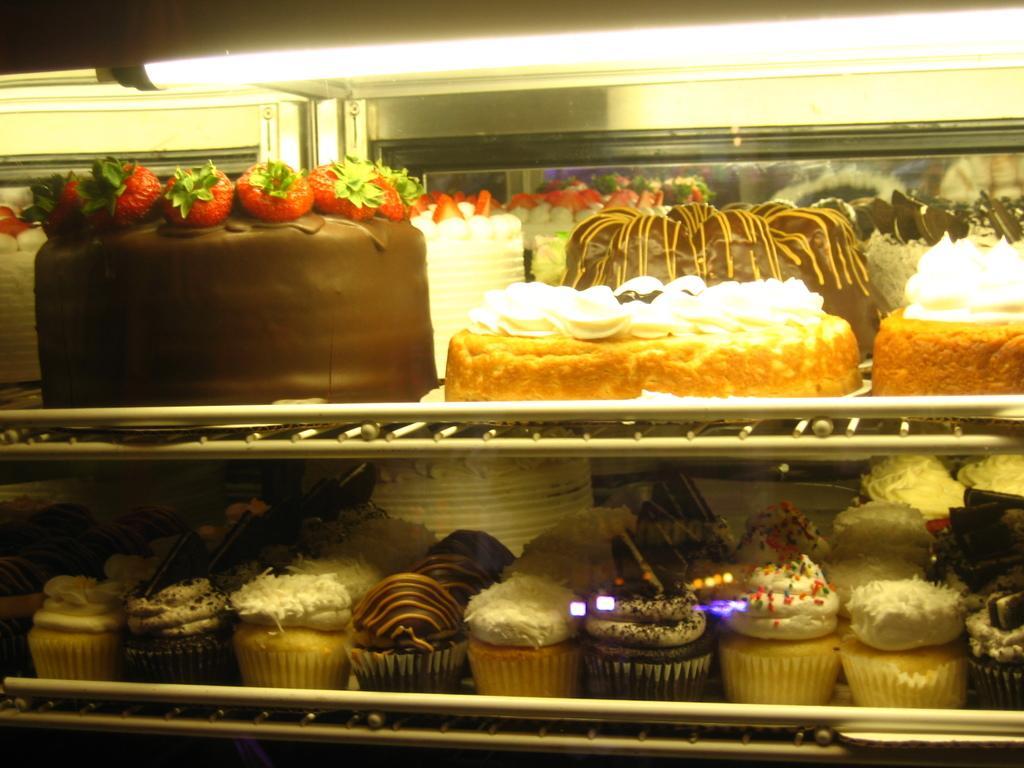How would you summarize this image in a sentence or two? In this image I can see number of cakes and a light on the top side. On the bottom side of this image I can see number of cupcakes. 